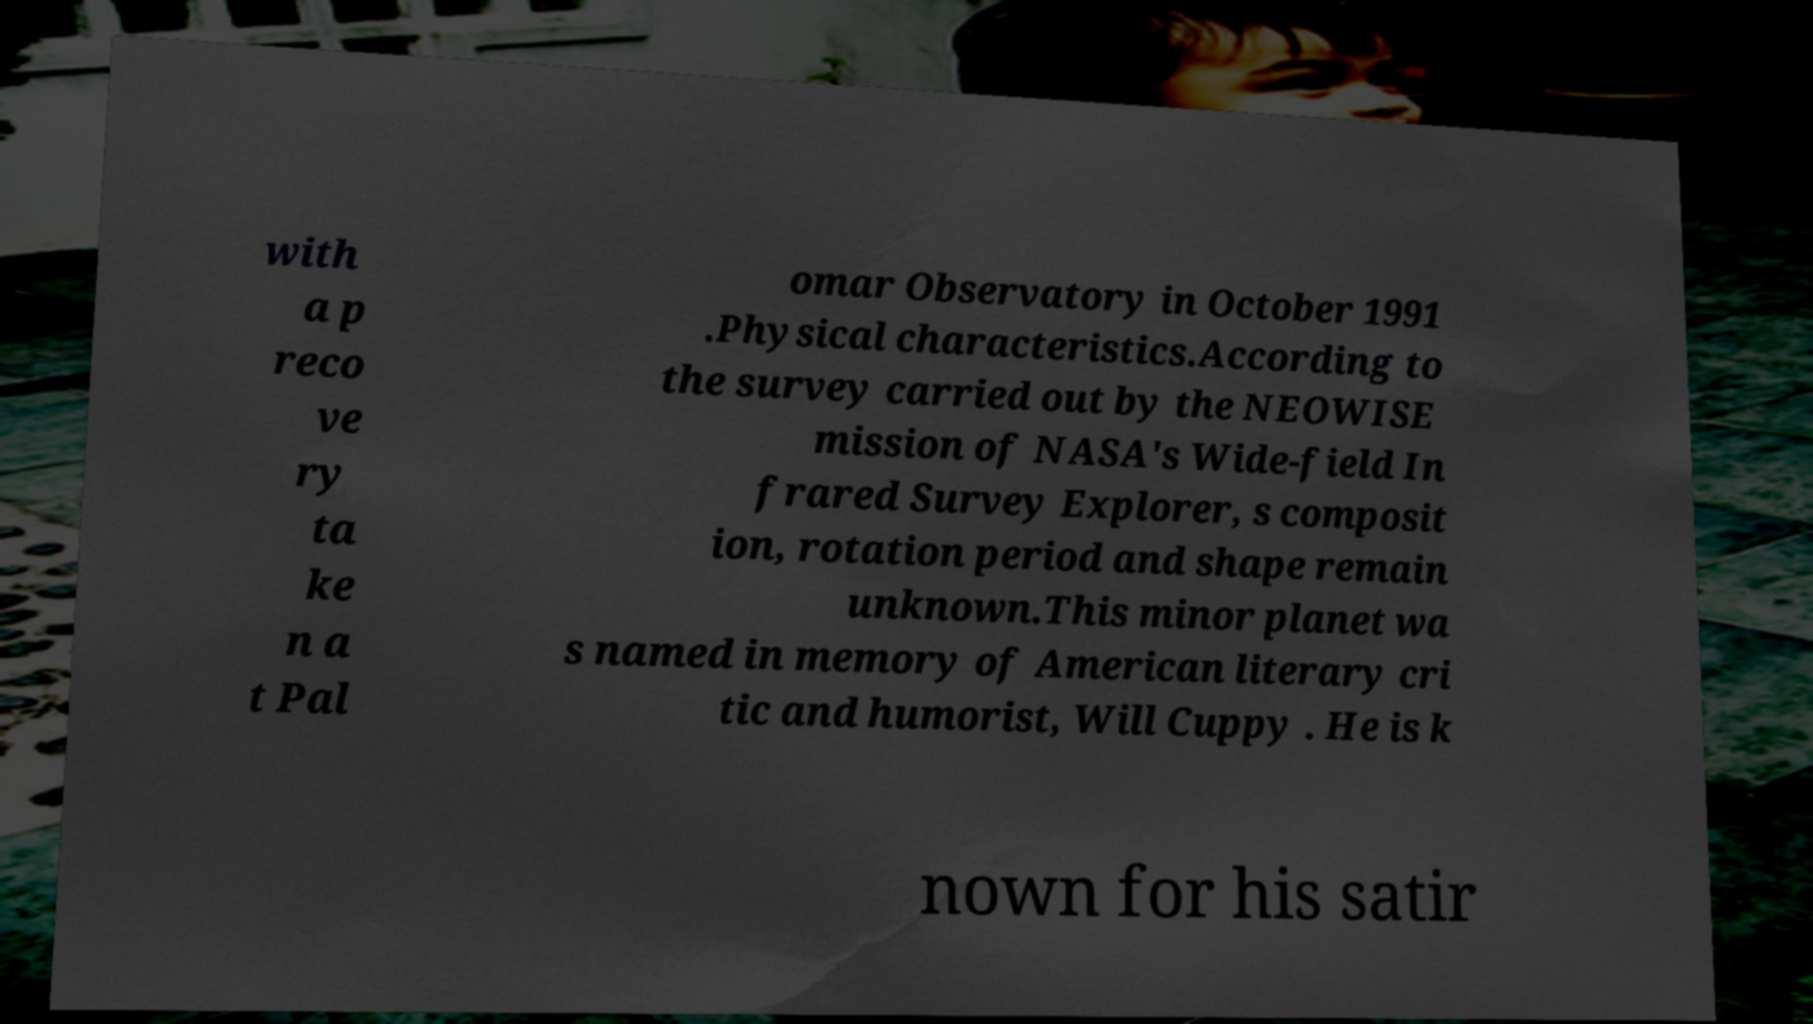What messages or text are displayed in this image? I need them in a readable, typed format. with a p reco ve ry ta ke n a t Pal omar Observatory in October 1991 .Physical characteristics.According to the survey carried out by the NEOWISE mission of NASA's Wide-field In frared Survey Explorer, s composit ion, rotation period and shape remain unknown.This minor planet wa s named in memory of American literary cri tic and humorist, Will Cuppy . He is k nown for his satir 